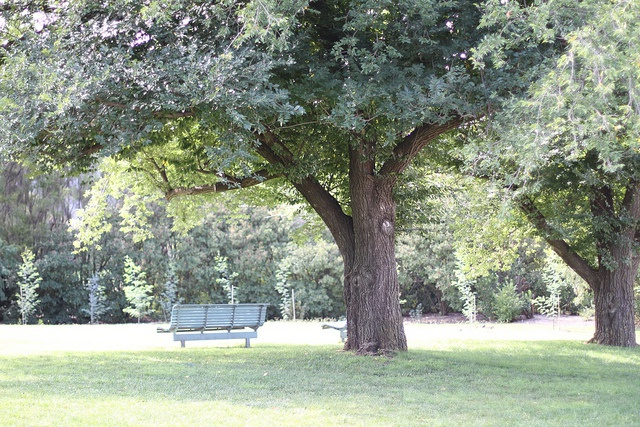Describe the objects in this image and their specific colors. I can see a bench in white, lightblue, darkgray, and lightgray tones in this image. 